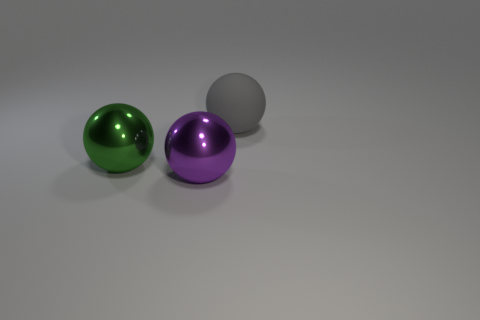Is the number of gray balls left of the purple metallic sphere greater than the number of green metal cylinders?
Ensure brevity in your answer.  No. Is the shape of the green thing the same as the object that is right of the purple metallic ball?
Keep it short and to the point. Yes. Is there any other thing that has the same size as the purple metal sphere?
Your answer should be compact. Yes. There is a purple thing that is the same shape as the gray thing; what is its size?
Your answer should be compact. Large. Are there more large blue blocks than purple metallic spheres?
Keep it short and to the point. No. Is the shape of the large gray object the same as the large green object?
Offer a very short reply. Yes. There is a big sphere that is to the left of the big metallic thing that is in front of the big green object; what is it made of?
Make the answer very short. Metal. Do the matte sphere and the green shiny ball have the same size?
Give a very brief answer. Yes. Is there a green metallic thing that is right of the sphere behind the green metal ball?
Your response must be concise. No. What shape is the large green metal object to the left of the purple metallic ball?
Give a very brief answer. Sphere. 